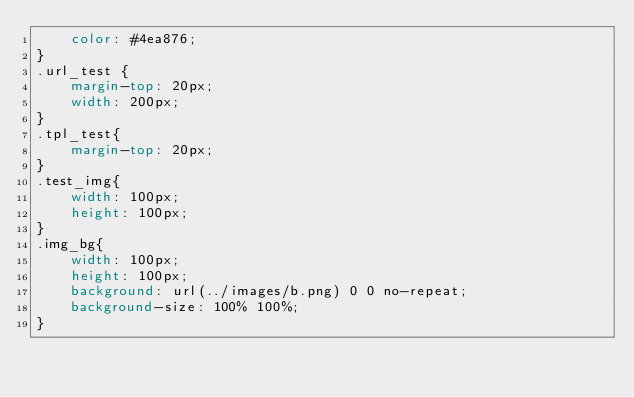Convert code to text. <code><loc_0><loc_0><loc_500><loc_500><_CSS_>    color: #4ea876;
}
.url_test {
    margin-top: 20px;
    width: 200px;
}
.tpl_test{
    margin-top: 20px;
}
.test_img{
    width: 100px;
    height: 100px;
}
.img_bg{
    width: 100px;
    height: 100px;
    background: url(../images/b.png) 0 0 no-repeat;
    background-size: 100% 100%;
}</code> 